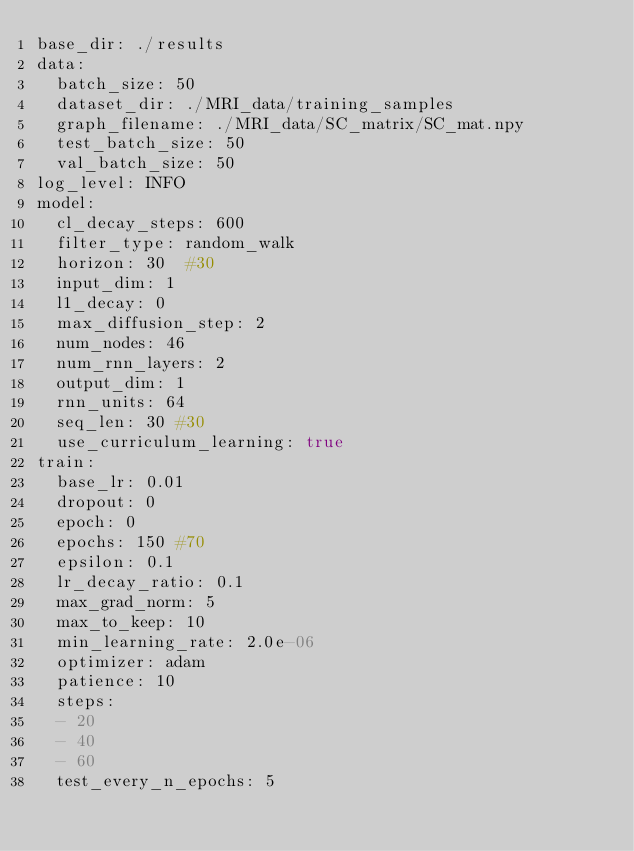<code> <loc_0><loc_0><loc_500><loc_500><_YAML_>base_dir: ./results
data:
  batch_size: 50
  dataset_dir: ./MRI_data/training_samples
  graph_filename: ./MRI_data/SC_matrix/SC_mat.npy
  test_batch_size: 50
  val_batch_size: 50
log_level: INFO
model:
  cl_decay_steps: 600
  filter_type: random_walk
  horizon: 30  #30
  input_dim: 1
  l1_decay: 0
  max_diffusion_step: 2
  num_nodes: 46
  num_rnn_layers: 2
  output_dim: 1
  rnn_units: 64
  seq_len: 30 #30
  use_curriculum_learning: true
train:
  base_lr: 0.01
  dropout: 0
  epoch: 0
  epochs: 150 #70
  epsilon: 0.1
  lr_decay_ratio: 0.1
  max_grad_norm: 5
  max_to_keep: 10
  min_learning_rate: 2.0e-06
  optimizer: adam
  patience: 10
  steps:
  - 20
  - 40
  - 60
  test_every_n_epochs: 5
</code> 